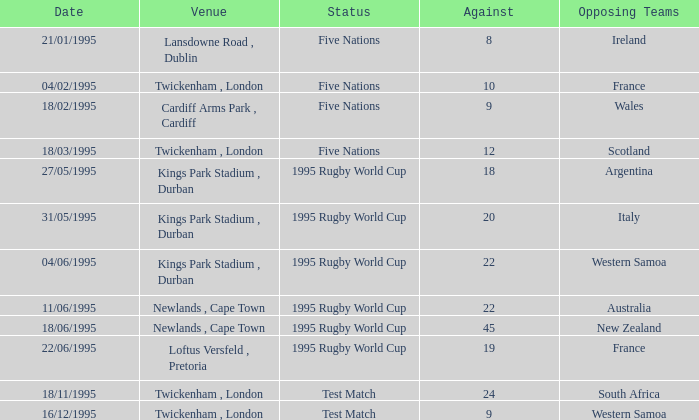What's the status on 16/12/1995? Test Match. 